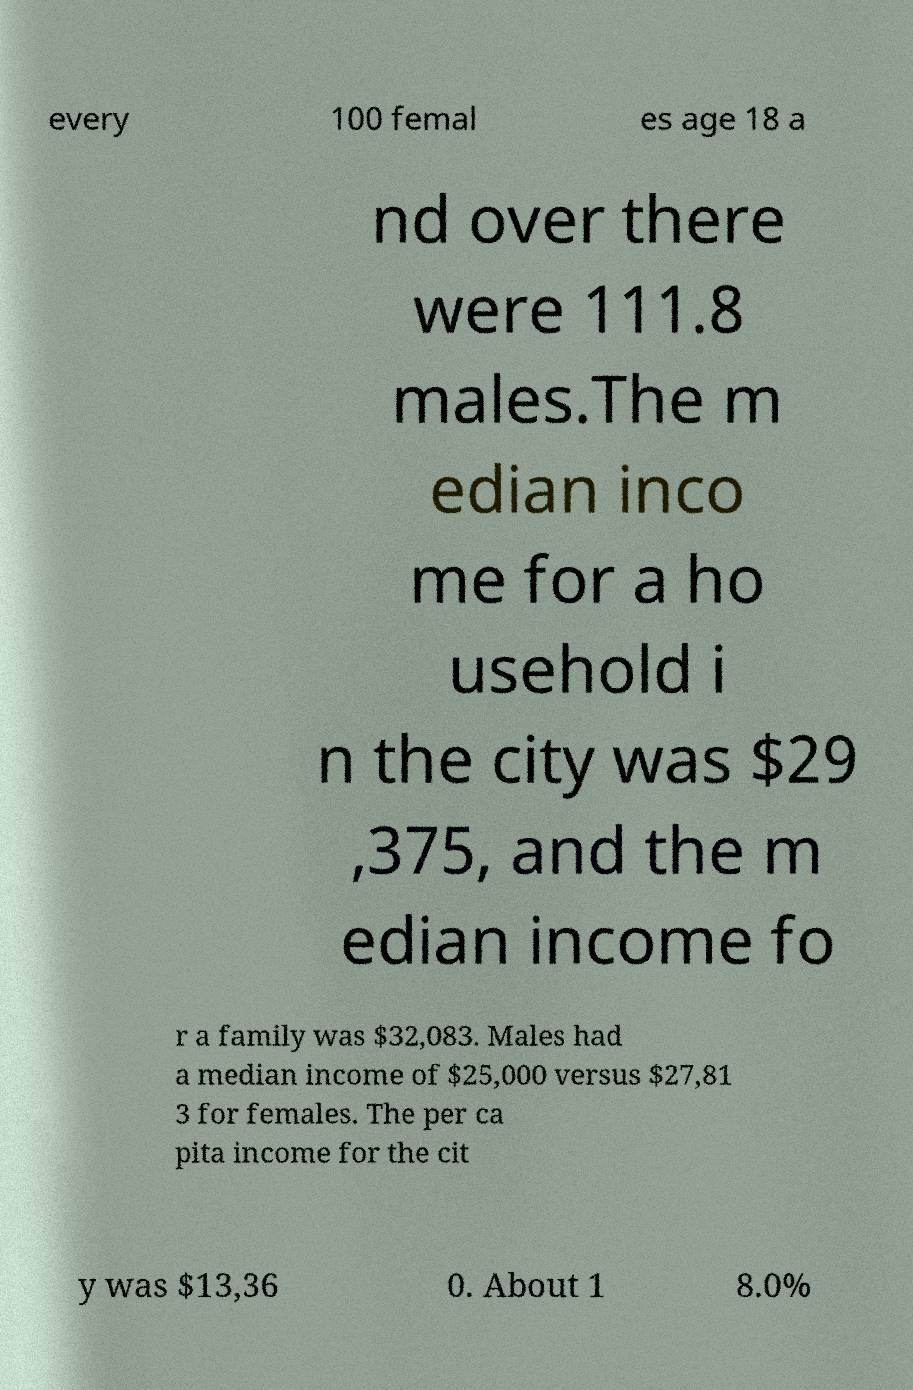Please read and relay the text visible in this image. What does it say? every 100 femal es age 18 a nd over there were 111.8 males.The m edian inco me for a ho usehold i n the city was $29 ,375, and the m edian income fo r a family was $32,083. Males had a median income of $25,000 versus $27,81 3 for females. The per ca pita income for the cit y was $13,36 0. About 1 8.0% 